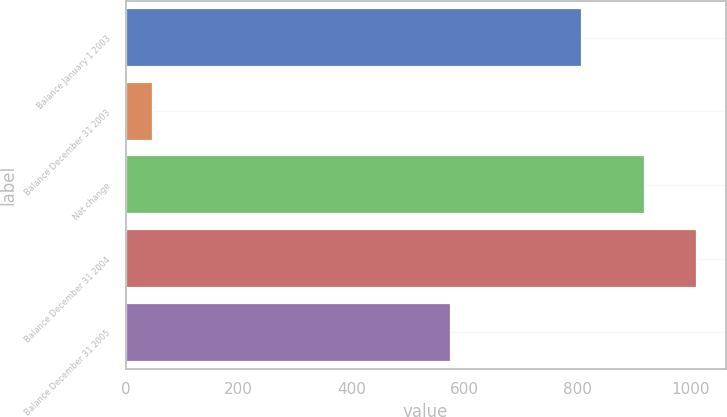Convert chart. <chart><loc_0><loc_0><loc_500><loc_500><bar_chart><fcel>Balance January 1 2003<fcel>Balance December 31 2003<fcel>Net change<fcel>Balance December 31 2004<fcel>Balance December 31 2005<nl><fcel>809<fcel>49<fcel>920<fcel>1012<fcel>577<nl></chart> 